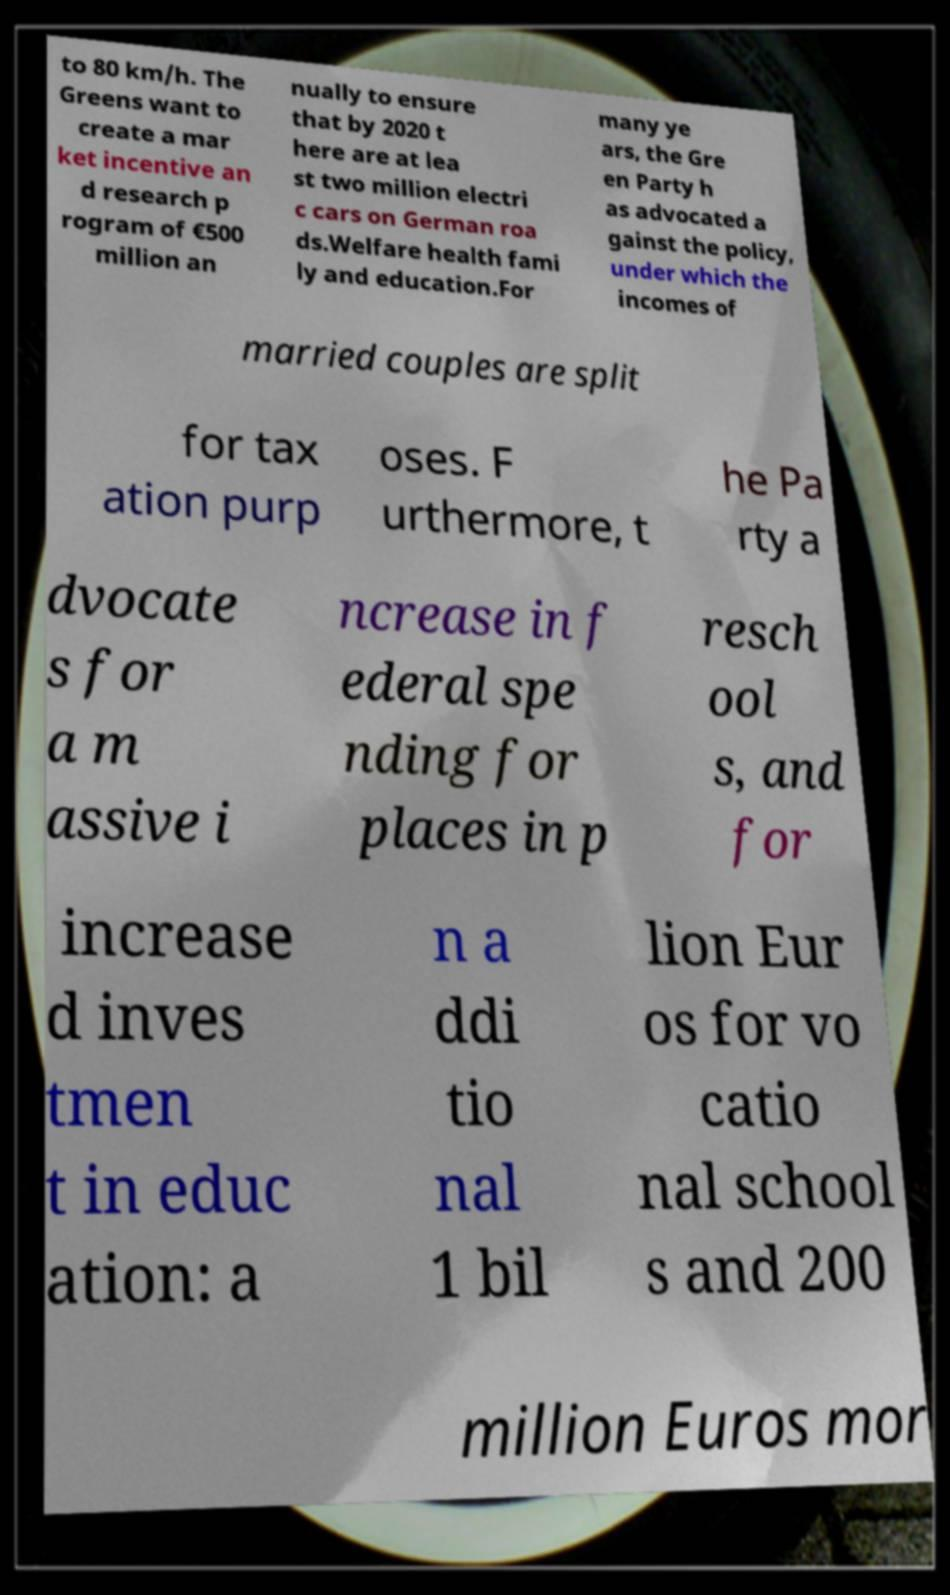There's text embedded in this image that I need extracted. Can you transcribe it verbatim? to 80 km/h. The Greens want to create a mar ket incentive an d research p rogram of €500 million an nually to ensure that by 2020 t here are at lea st two million electri c cars on German roa ds.Welfare health fami ly and education.For many ye ars, the Gre en Party h as advocated a gainst the policy, under which the incomes of married couples are split for tax ation purp oses. F urthermore, t he Pa rty a dvocate s for a m assive i ncrease in f ederal spe nding for places in p resch ool s, and for increase d inves tmen t in educ ation: a n a ddi tio nal 1 bil lion Eur os for vo catio nal school s and 200 million Euros mor 